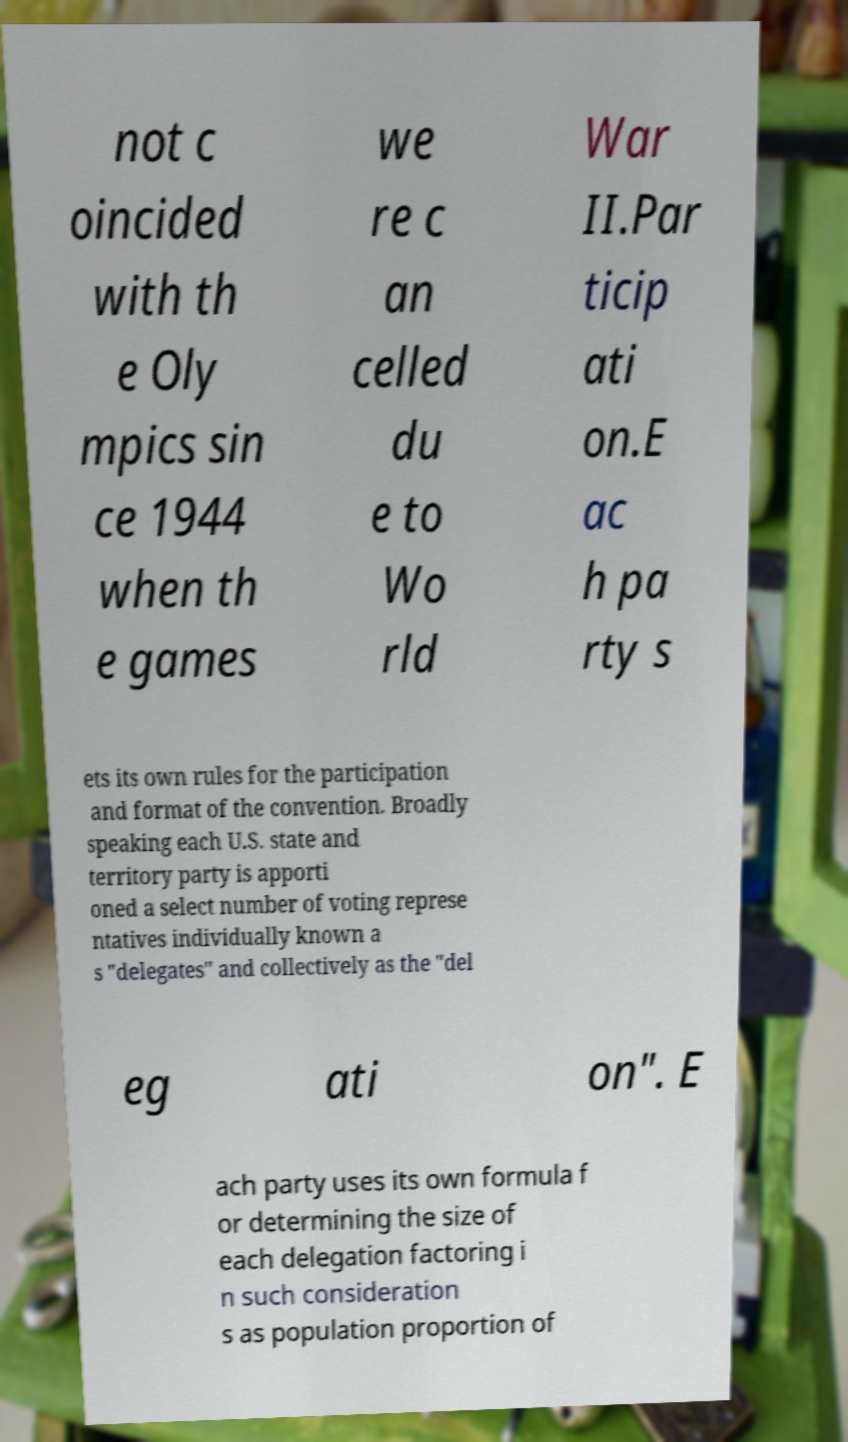For documentation purposes, I need the text within this image transcribed. Could you provide that? not c oincided with th e Oly mpics sin ce 1944 when th e games we re c an celled du e to Wo rld War II.Par ticip ati on.E ac h pa rty s ets its own rules for the participation and format of the convention. Broadly speaking each U.S. state and territory party is apporti oned a select number of voting represe ntatives individually known a s "delegates" and collectively as the "del eg ati on". E ach party uses its own formula f or determining the size of each delegation factoring i n such consideration s as population proportion of 